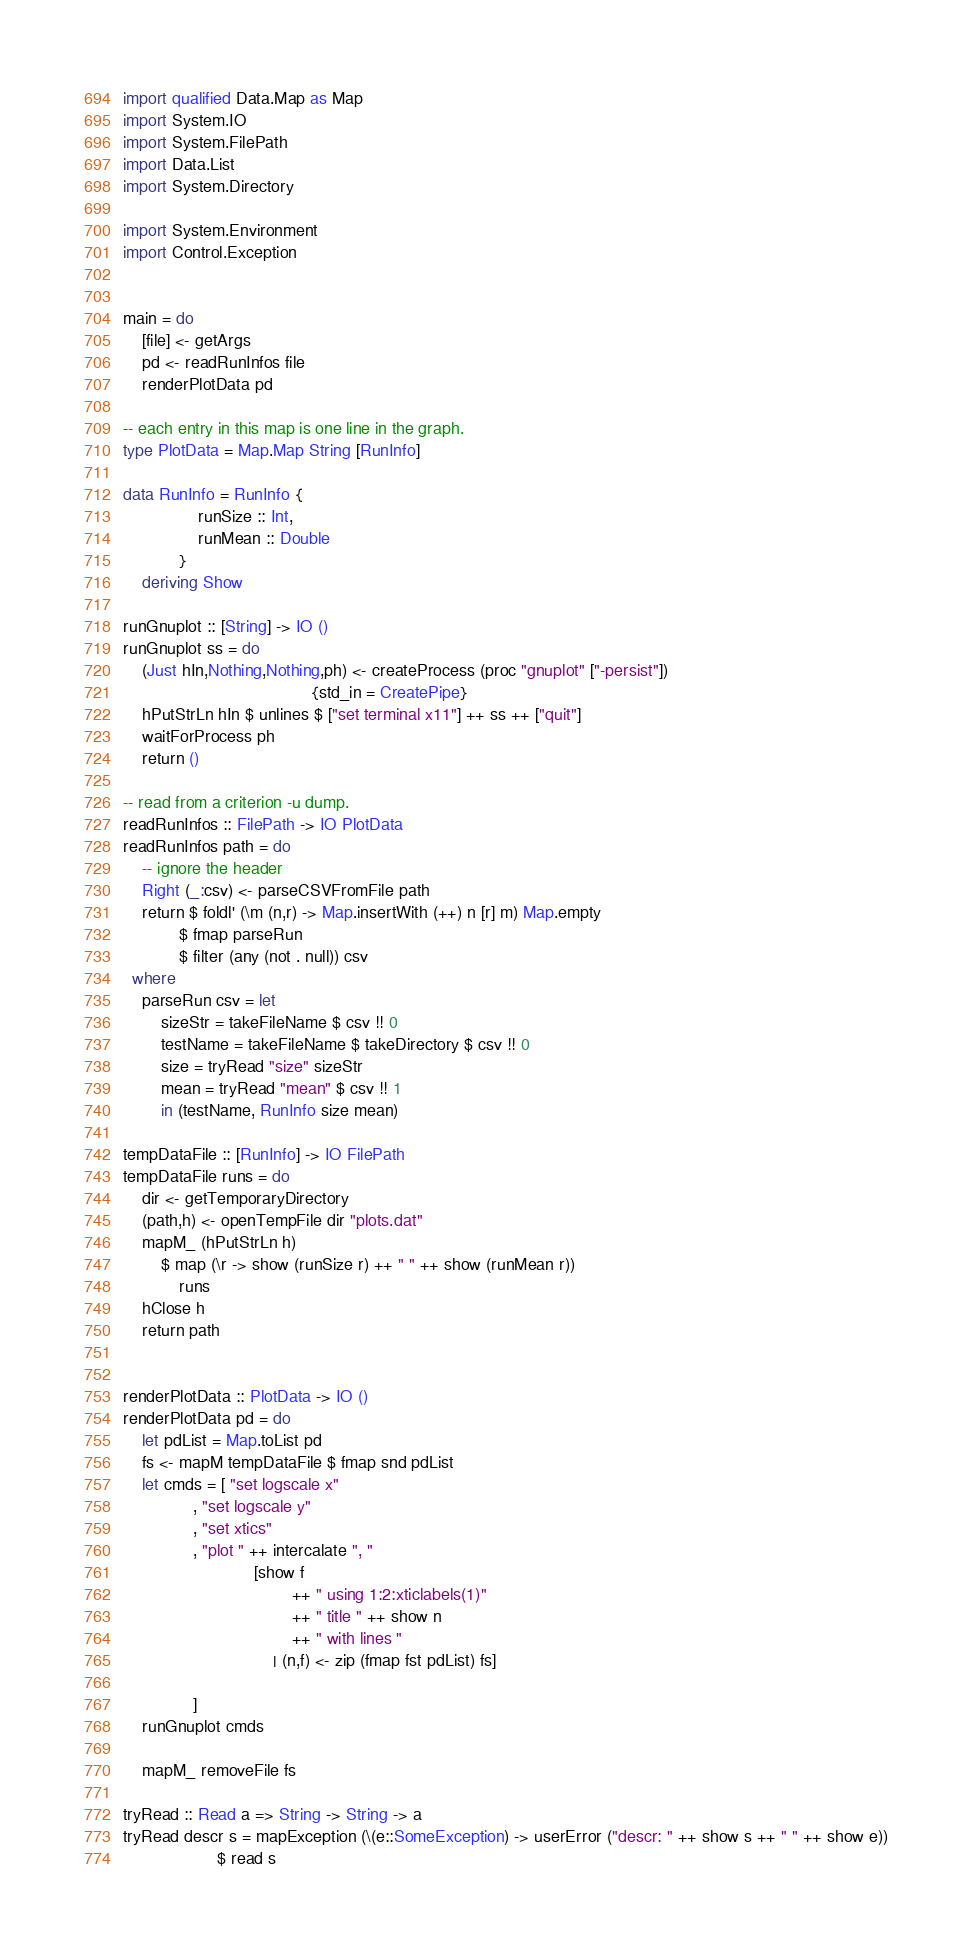Convert code to text. <code><loc_0><loc_0><loc_500><loc_500><_Haskell_>import qualified Data.Map as Map
import System.IO
import System.FilePath
import Data.List
import System.Directory

import System.Environment
import Control.Exception


main = do
    [file] <- getArgs
    pd <- readRunInfos file
    renderPlotData pd

-- each entry in this map is one line in the graph.
type PlotData = Map.Map String [RunInfo]

data RunInfo = RunInfo {
                runSize :: Int,
                runMean :: Double 
            }
    deriving Show

runGnuplot :: [String] -> IO ()
runGnuplot ss = do
    (Just hIn,Nothing,Nothing,ph) <- createProcess (proc "gnuplot" ["-persist"])
                                        {std_in = CreatePipe}
    hPutStrLn hIn $ unlines $ ["set terminal x11"] ++ ss ++ ["quit"]
    waitForProcess ph
    return ()

-- read from a criterion -u dump.       
readRunInfos :: FilePath -> IO PlotData
readRunInfos path = do
    -- ignore the header
    Right (_:csv) <- parseCSVFromFile path
    return $ foldl' (\m (n,r) -> Map.insertWith (++) n [r] m) Map.empty
            $ fmap parseRun
            $ filter (any (not . null)) csv
  where
    parseRun csv = let
        sizeStr = takeFileName $ csv !! 0
        testName = takeFileName $ takeDirectory $ csv !! 0
        size = tryRead "size" sizeStr
        mean = tryRead "mean" $ csv !! 1
        in (testName, RunInfo size mean)

tempDataFile :: [RunInfo] -> IO FilePath
tempDataFile runs = do
    dir <- getTemporaryDirectory
    (path,h) <- openTempFile dir "plots.dat"
    mapM_ (hPutStrLn h)
        $ map (\r -> show (runSize r) ++ " " ++ show (runMean r))
            runs
    hClose h
    return path
                    

renderPlotData :: PlotData -> IO ()
renderPlotData pd = do
    let pdList = Map.toList pd
    fs <- mapM tempDataFile $ fmap snd pdList
    let cmds = [ "set logscale x"
               , "set logscale y"
               , "set xtics"
               , "plot " ++ intercalate ", " 
                            [show f 
                                    ++ " using 1:2:xticlabels(1)"
                                    ++ " title " ++ show n
                                    ++ " with lines "
                                | (n,f) <- zip (fmap fst pdList) fs]

               ]
    runGnuplot cmds
    
    mapM_ removeFile fs

tryRead :: Read a => String -> String -> a
tryRead descr s = mapException (\(e::SomeException) -> userError ("descr: " ++ show s ++ " " ++ show e))
                    $ read s
</code> 